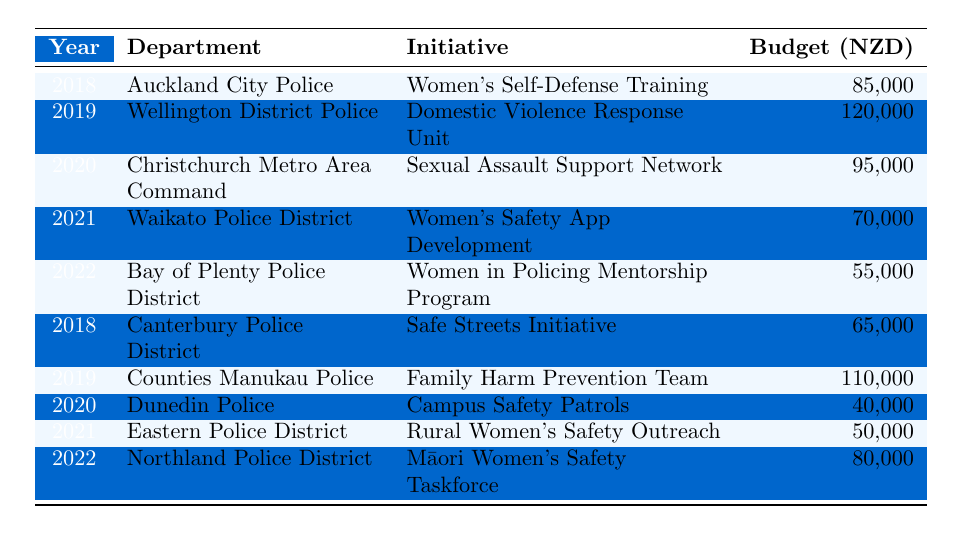What was the highest budget allocated for a women's safety initiative? By reviewing the budget values in the table, the highest allocation is found in 2019 for the Wellington District Police's Domestic Violence Response Unit, with a budget of 120,000 NZD.
Answer: 120,000 NZD Which police department had the lowest budget allocation in the table? Upon inspecting the budgets, Dunedin Police had the lowest allocation of 40,000 NZD for the Campus Safety Patrols initiative in 2020.
Answer: Dunedin Police, 40,000 NZD How many initiatives had a budget of 70,000 NZD or above? Counting the initiatives with budgets of 70,000 NZD or more: Auckland City (85,000), Wellington District (120,000), Christchurch Metro (95,000), Counties Manukau (110,000), and Northland (80,000). That totals to 5 initiatives.
Answer: 5 What is the total budget allocated for women's safety initiatives in 2022? Looking at the table, the budgets for 2022 are from Bay of Plenty (55,000) and Northland (80,000). The total for these two is 55,000 + 80,000 = 135,000 NZD.
Answer: 135,000 NZD Is the initiative "Women's Self-Defense Training" from Auckland City Police the only initiative from 2018? Checking the table, there are two initiatives listed for 2018: Auckland City Police's Women's Self-Defense Training and Canterbury Police District's Safe Streets Initiative. Thus, the statement is false.
Answer: No Which year had the greatest total budget allocation across all initiatives? To find the year with the highest total, we must add the budgets for each year. 2018 totals to 85,000 + 65,000 = 150,000; 2019 totals to 120,000 + 110,000 = 230,000; 2020 totals to 95,000 + 40,000 = 135,000; 2021 totals to 70,000 + 50,000 = 120,000; and 2022 totals to 55,000 + 80,000 = 135,000. The greatest total is from 2019, which is 230,000 NZD.
Answer: 2019 How many police departments initiated programs focused on women's safety in 2020? In 2020, there were two initiatives: the Sexual Assault Support Network (Christchurch Metro) and Campus Safety Patrols (Dunedin Police), meaning two police departments initiated programs that year.
Answer: 2 What is the average budget allocation for the initiatives in 2021? The budgets for 2021 are 70,000 (Waikato) and 50,000 (Eastern). Adding these gives 70,000 + 50,000 = 120,000, and dividing by the number of initiatives (2) gives an average of 120,000 / 2 = 60,000 NZD.
Answer: 60,000 NZD Does the table include any initiatives specifically targeting Māori women? The table presents the Māori Women's Safety Taskforce from the Northland Police District in 2022, which specifically addresses the safety of Māori women, thus confirming the existence of such an initiative.
Answer: Yes 